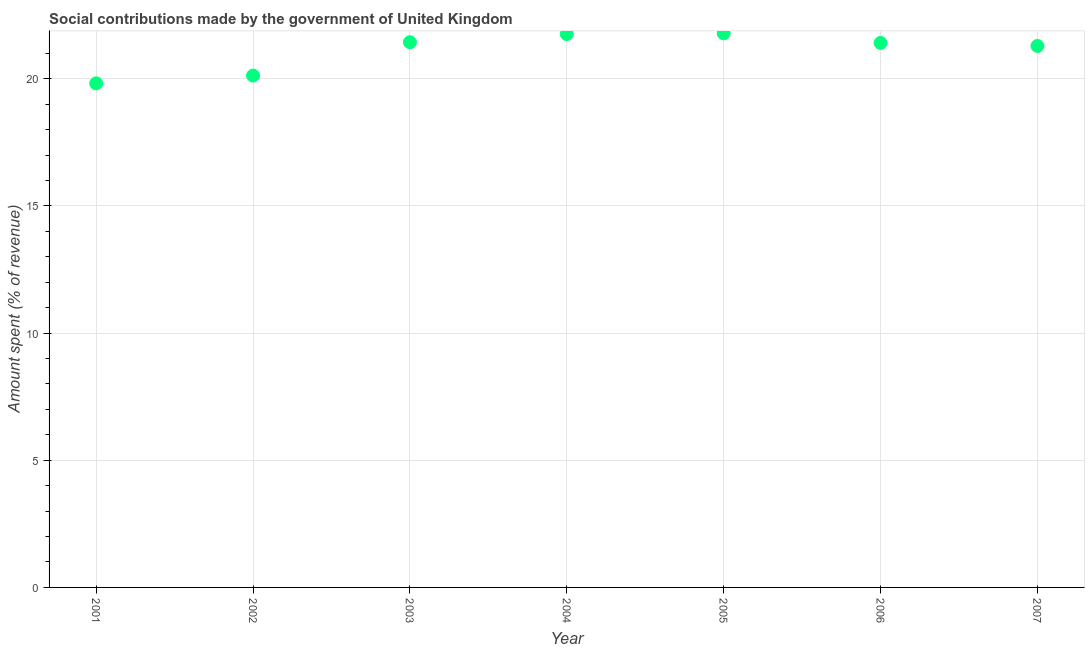What is the amount spent in making social contributions in 2006?
Your answer should be very brief. 21.41. Across all years, what is the maximum amount spent in making social contributions?
Your answer should be very brief. 21.78. Across all years, what is the minimum amount spent in making social contributions?
Give a very brief answer. 19.82. In which year was the amount spent in making social contributions maximum?
Your answer should be very brief. 2005. What is the sum of the amount spent in making social contributions?
Keep it short and to the point. 147.61. What is the difference between the amount spent in making social contributions in 2001 and 2004?
Offer a very short reply. -1.94. What is the average amount spent in making social contributions per year?
Make the answer very short. 21.09. What is the median amount spent in making social contributions?
Offer a terse response. 21.41. In how many years, is the amount spent in making social contributions greater than 4 %?
Your response must be concise. 7. Do a majority of the years between 2002 and 2007 (inclusive) have amount spent in making social contributions greater than 16 %?
Provide a succinct answer. Yes. What is the ratio of the amount spent in making social contributions in 2004 to that in 2007?
Your answer should be compact. 1.02. What is the difference between the highest and the second highest amount spent in making social contributions?
Keep it short and to the point. 0.03. Is the sum of the amount spent in making social contributions in 2005 and 2007 greater than the maximum amount spent in making social contributions across all years?
Offer a very short reply. Yes. What is the difference between the highest and the lowest amount spent in making social contributions?
Give a very brief answer. 1.97. In how many years, is the amount spent in making social contributions greater than the average amount spent in making social contributions taken over all years?
Provide a short and direct response. 5. How many dotlines are there?
Give a very brief answer. 1. How many years are there in the graph?
Your response must be concise. 7. What is the difference between two consecutive major ticks on the Y-axis?
Make the answer very short. 5. Does the graph contain any zero values?
Offer a very short reply. No. Does the graph contain grids?
Your answer should be very brief. Yes. What is the title of the graph?
Ensure brevity in your answer.  Social contributions made by the government of United Kingdom. What is the label or title of the Y-axis?
Keep it short and to the point. Amount spent (% of revenue). What is the Amount spent (% of revenue) in 2001?
Provide a succinct answer. 19.82. What is the Amount spent (% of revenue) in 2002?
Your answer should be compact. 20.12. What is the Amount spent (% of revenue) in 2003?
Give a very brief answer. 21.44. What is the Amount spent (% of revenue) in 2004?
Give a very brief answer. 21.76. What is the Amount spent (% of revenue) in 2005?
Give a very brief answer. 21.78. What is the Amount spent (% of revenue) in 2006?
Offer a terse response. 21.41. What is the Amount spent (% of revenue) in 2007?
Your response must be concise. 21.29. What is the difference between the Amount spent (% of revenue) in 2001 and 2002?
Keep it short and to the point. -0.31. What is the difference between the Amount spent (% of revenue) in 2001 and 2003?
Ensure brevity in your answer.  -1.62. What is the difference between the Amount spent (% of revenue) in 2001 and 2004?
Your answer should be very brief. -1.94. What is the difference between the Amount spent (% of revenue) in 2001 and 2005?
Make the answer very short. -1.97. What is the difference between the Amount spent (% of revenue) in 2001 and 2006?
Your response must be concise. -1.59. What is the difference between the Amount spent (% of revenue) in 2001 and 2007?
Make the answer very short. -1.47. What is the difference between the Amount spent (% of revenue) in 2002 and 2003?
Offer a terse response. -1.31. What is the difference between the Amount spent (% of revenue) in 2002 and 2004?
Ensure brevity in your answer.  -1.63. What is the difference between the Amount spent (% of revenue) in 2002 and 2005?
Your response must be concise. -1.66. What is the difference between the Amount spent (% of revenue) in 2002 and 2006?
Your answer should be compact. -1.28. What is the difference between the Amount spent (% of revenue) in 2002 and 2007?
Make the answer very short. -1.16. What is the difference between the Amount spent (% of revenue) in 2003 and 2004?
Your response must be concise. -0.32. What is the difference between the Amount spent (% of revenue) in 2003 and 2005?
Your response must be concise. -0.35. What is the difference between the Amount spent (% of revenue) in 2003 and 2006?
Offer a terse response. 0.03. What is the difference between the Amount spent (% of revenue) in 2003 and 2007?
Your answer should be compact. 0.15. What is the difference between the Amount spent (% of revenue) in 2004 and 2005?
Give a very brief answer. -0.03. What is the difference between the Amount spent (% of revenue) in 2004 and 2006?
Offer a very short reply. 0.35. What is the difference between the Amount spent (% of revenue) in 2004 and 2007?
Make the answer very short. 0.47. What is the difference between the Amount spent (% of revenue) in 2005 and 2006?
Give a very brief answer. 0.38. What is the difference between the Amount spent (% of revenue) in 2005 and 2007?
Your answer should be compact. 0.5. What is the difference between the Amount spent (% of revenue) in 2006 and 2007?
Give a very brief answer. 0.12. What is the ratio of the Amount spent (% of revenue) in 2001 to that in 2003?
Provide a succinct answer. 0.92. What is the ratio of the Amount spent (% of revenue) in 2001 to that in 2004?
Your response must be concise. 0.91. What is the ratio of the Amount spent (% of revenue) in 2001 to that in 2005?
Your answer should be very brief. 0.91. What is the ratio of the Amount spent (% of revenue) in 2001 to that in 2006?
Offer a terse response. 0.93. What is the ratio of the Amount spent (% of revenue) in 2001 to that in 2007?
Ensure brevity in your answer.  0.93. What is the ratio of the Amount spent (% of revenue) in 2002 to that in 2003?
Provide a short and direct response. 0.94. What is the ratio of the Amount spent (% of revenue) in 2002 to that in 2004?
Your answer should be very brief. 0.93. What is the ratio of the Amount spent (% of revenue) in 2002 to that in 2005?
Provide a succinct answer. 0.92. What is the ratio of the Amount spent (% of revenue) in 2002 to that in 2007?
Provide a succinct answer. 0.94. What is the ratio of the Amount spent (% of revenue) in 2003 to that in 2004?
Your answer should be compact. 0.98. What is the ratio of the Amount spent (% of revenue) in 2003 to that in 2005?
Offer a terse response. 0.98. What is the ratio of the Amount spent (% of revenue) in 2003 to that in 2006?
Provide a short and direct response. 1. What is the ratio of the Amount spent (% of revenue) in 2003 to that in 2007?
Keep it short and to the point. 1.01. What is the ratio of the Amount spent (% of revenue) in 2005 to that in 2007?
Your answer should be compact. 1.02. What is the ratio of the Amount spent (% of revenue) in 2006 to that in 2007?
Keep it short and to the point. 1.01. 